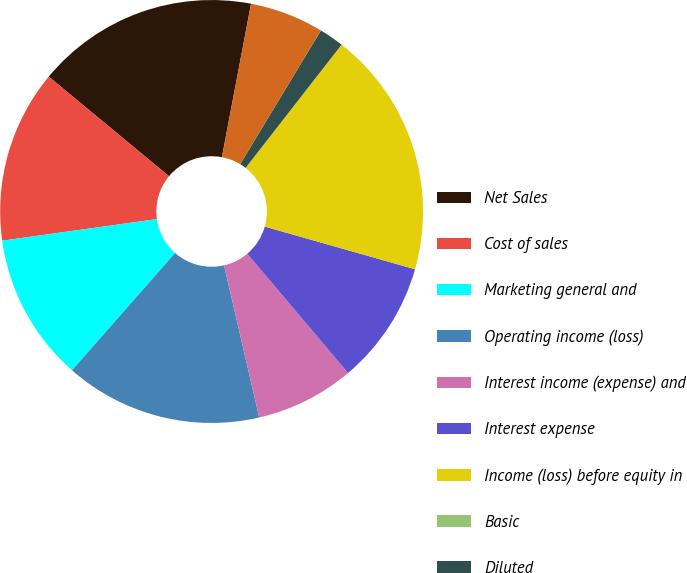<chart> <loc_0><loc_0><loc_500><loc_500><pie_chart><fcel>Net Sales<fcel>Cost of sales<fcel>Marketing general and<fcel>Operating income (loss)<fcel>Interest income (expense) and<fcel>Interest expense<fcel>Income (loss) before equity in<fcel>Basic<fcel>Diluted<fcel>High<nl><fcel>16.98%<fcel>13.21%<fcel>11.32%<fcel>15.09%<fcel>7.55%<fcel>9.43%<fcel>18.87%<fcel>0.0%<fcel>1.89%<fcel>5.66%<nl></chart> 